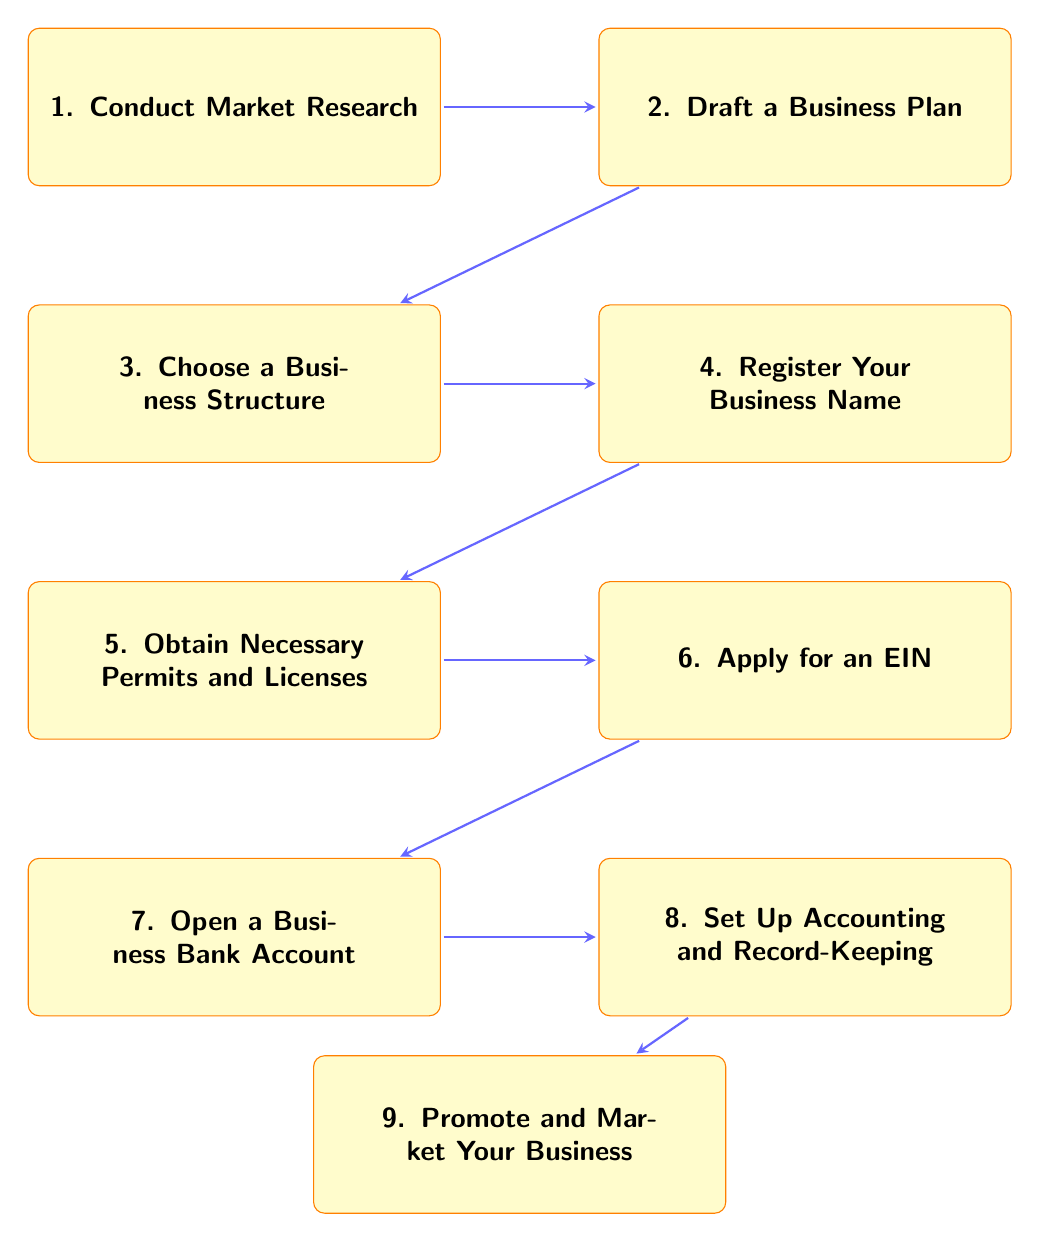What is the first step in the diagram? The first step listed in the diagram is at the top, which is "Conduct Market Research." This is the starting point of the flow chart outlining the steps to register a new business.
Answer: Conduct Market Research How many steps are there in total? By counting the nodes in the diagram, there are nine distinct steps listed. This includes all the actions needed to register a new business.
Answer: 9 Which step comes directly after drafting a business plan? The diagram shows that after "Draft a Business Plan," the next step in the sequence is "Choose a Business Structure," which flows directly downwards.
Answer: Choose a Business Structure What is the last step in the process? The last box at the bottom of the diagram represents the concluding action, which is "Promote and Market Your Business." This indicates the final stage of the registration process.
Answer: Promote and Market Your Business What action follows obtaining necessary permits and licenses? After "Obtain Necessary Permits and Licenses," the next step according to the arrows is "Apply for an Employer Identification Number (EIN)," indicating that taking care of permits is followed by EIN application.
Answer: Apply for an Employer Identification Number (EIN) What do steps three and four have in common? Both steps three ("Choose a Business Structure") and four ("Register Your Business Name") are crucial steps in the legal formation phase of the business registration process. They involve establishing legal identities for the business.
Answer: Legal formation Which step is a prerequisite for opening a business bank account? The diagram indicates that "Apply for an Employer Identification Number (EIN)" must be completed before one can "Open a Business Bank Account," as it is essential for banking activities and tax purposes.
Answer: Apply for an Employer Identification Number (EIN) What do you need to do first before drafting a business plan? According to the flow chart, before drafting a business plan, one must "Conduct Market Research," as it informs and shapes the content of the business plan that follows.
Answer: Conduct Market Research What is indicated by the flow from step two to step three? The arrow leading from "Draft a Business Plan" to "Choose a Business Structure" indicates that after completing the business plan, the next logical step in the business registration process is selecting the business structure.
Answer: Progression in process 